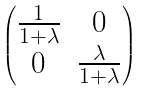Convert formula to latex. <formula><loc_0><loc_0><loc_500><loc_500>\begin{pmatrix} \frac { 1 } { 1 + \lambda } & 0 \\ 0 & \frac { \lambda } { 1 + \lambda } \\ \end{pmatrix}</formula> 